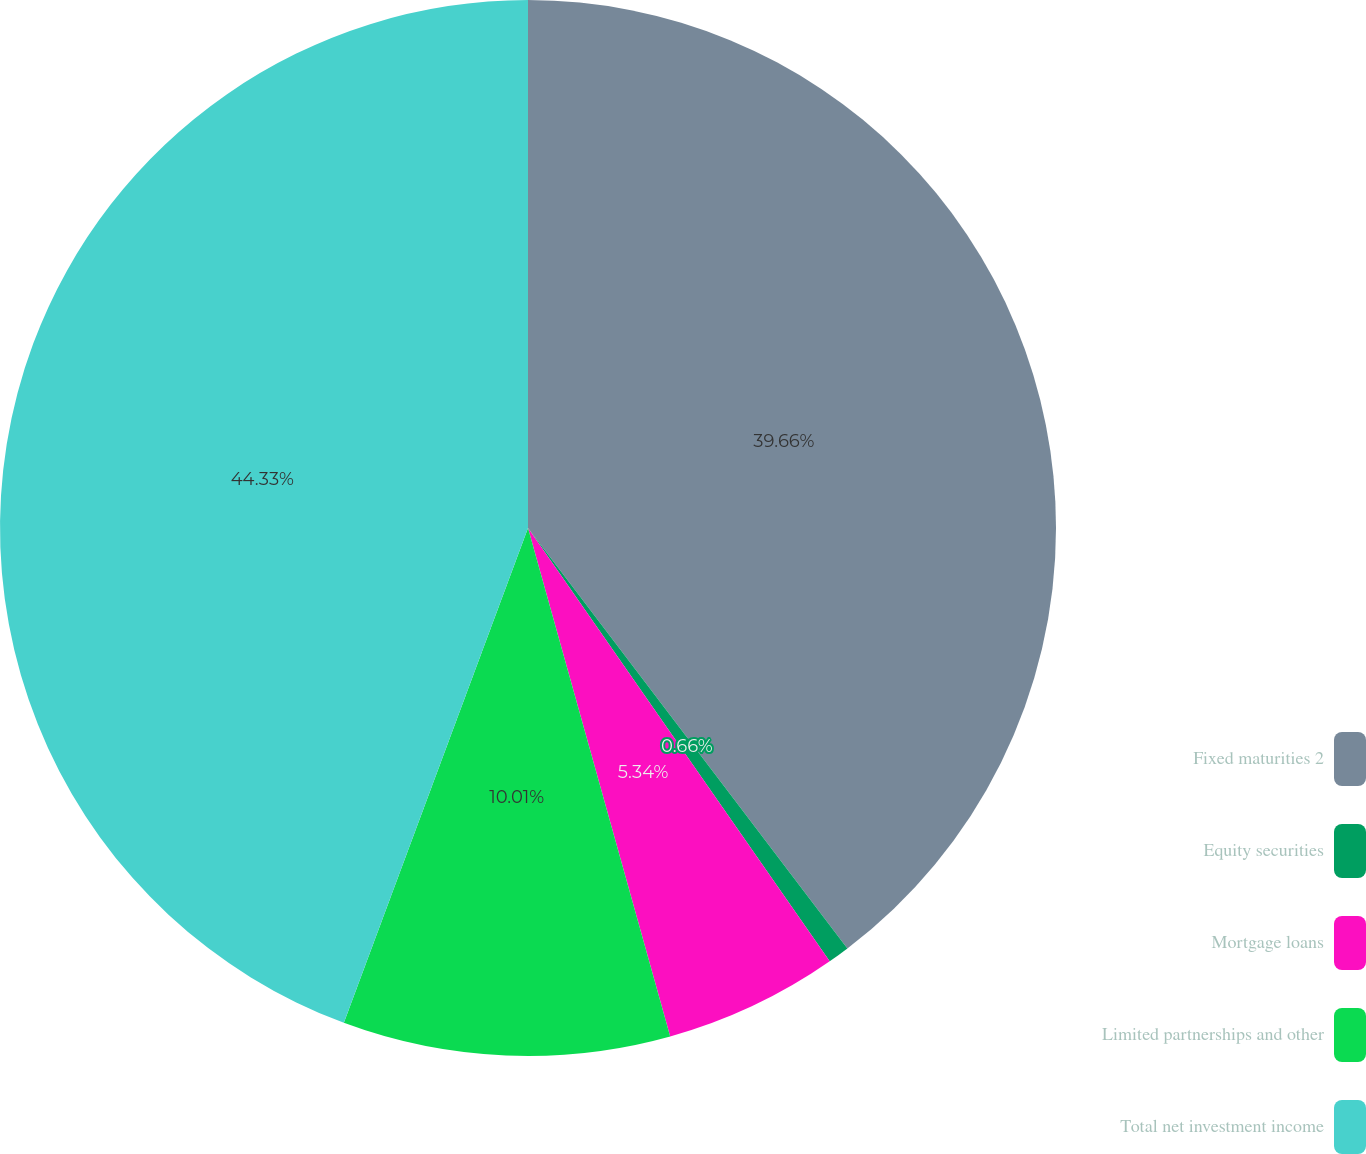Convert chart to OTSL. <chart><loc_0><loc_0><loc_500><loc_500><pie_chart><fcel>Fixed maturities 2<fcel>Equity securities<fcel>Mortgage loans<fcel>Limited partnerships and other<fcel>Total net investment income<nl><fcel>39.66%<fcel>0.66%<fcel>5.34%<fcel>10.01%<fcel>44.33%<nl></chart> 